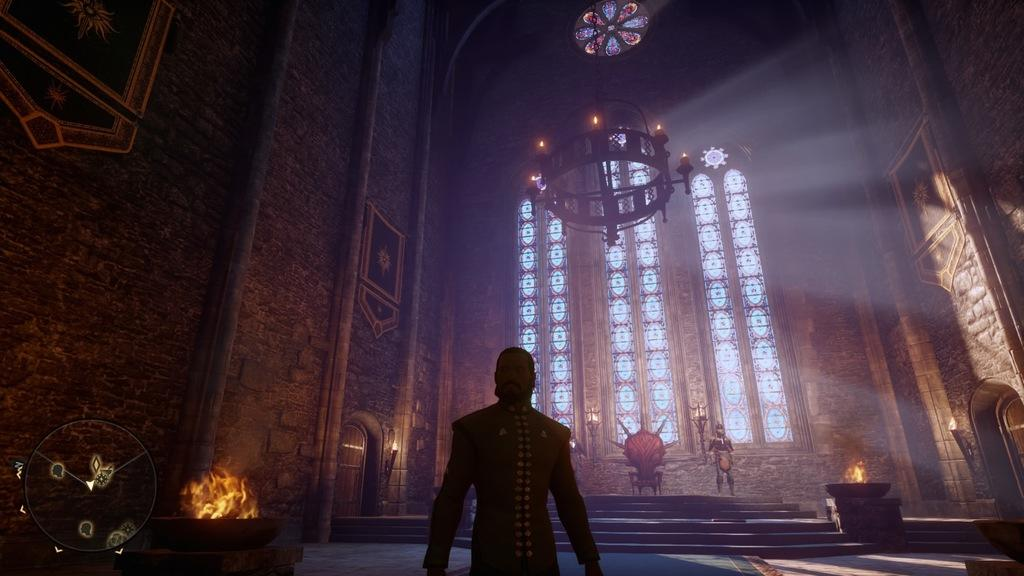Who or what is present at the bottom of the image? There is a person in the image, and they are at the bottom. What can be seen at the top of the image? There are lights at the top of the image. What type of furniture is present in the image? There are chairs in the image. What other objects or figures can be seen in the image? There are statues in the image. What type of toothpaste is being used by the person in the image? There is no toothpaste present in the image, and the person's actions are not described. 